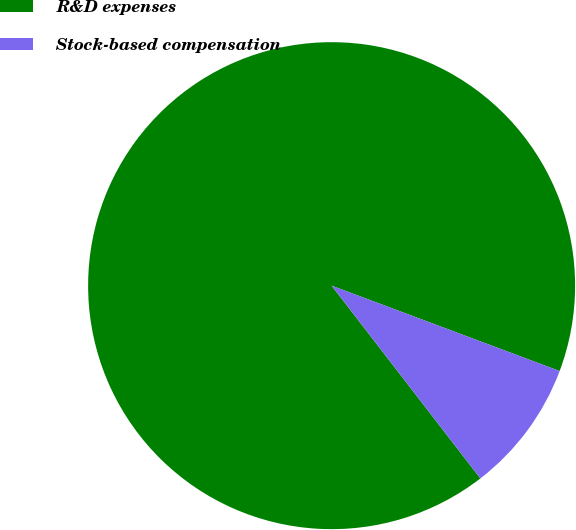Convert chart to OTSL. <chart><loc_0><loc_0><loc_500><loc_500><pie_chart><fcel>R&D expenses<fcel>Stock-based compensation<nl><fcel>91.16%<fcel>8.84%<nl></chart> 